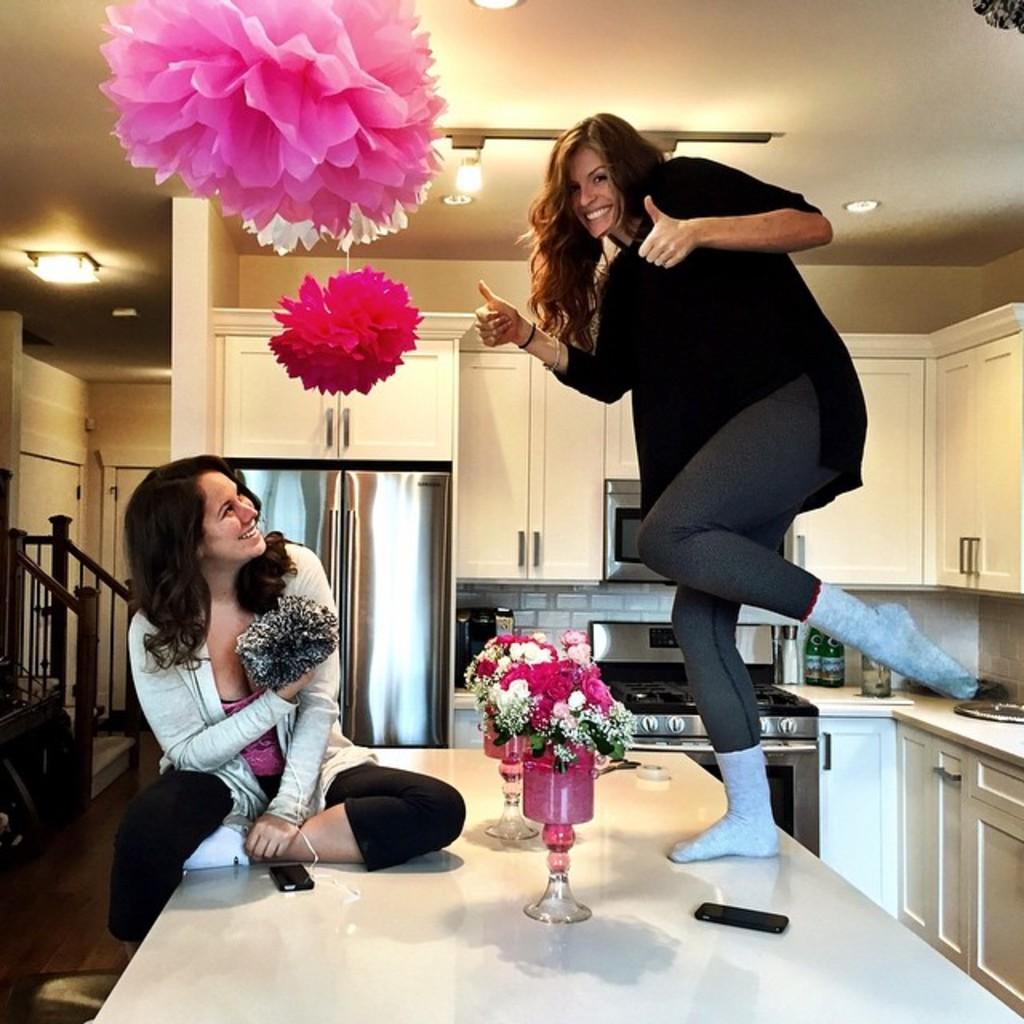How would you summarize this image in a sentence or two? Here we can see two women and the woman in the left is sitting on the table and the women in the right is standing on the table and between them there are flower vases and at the top left we can see some decoration flowers and there are lights everywhere, at the back side we can see stove and at the left side we can see refrigerator, both the are women are laughing 